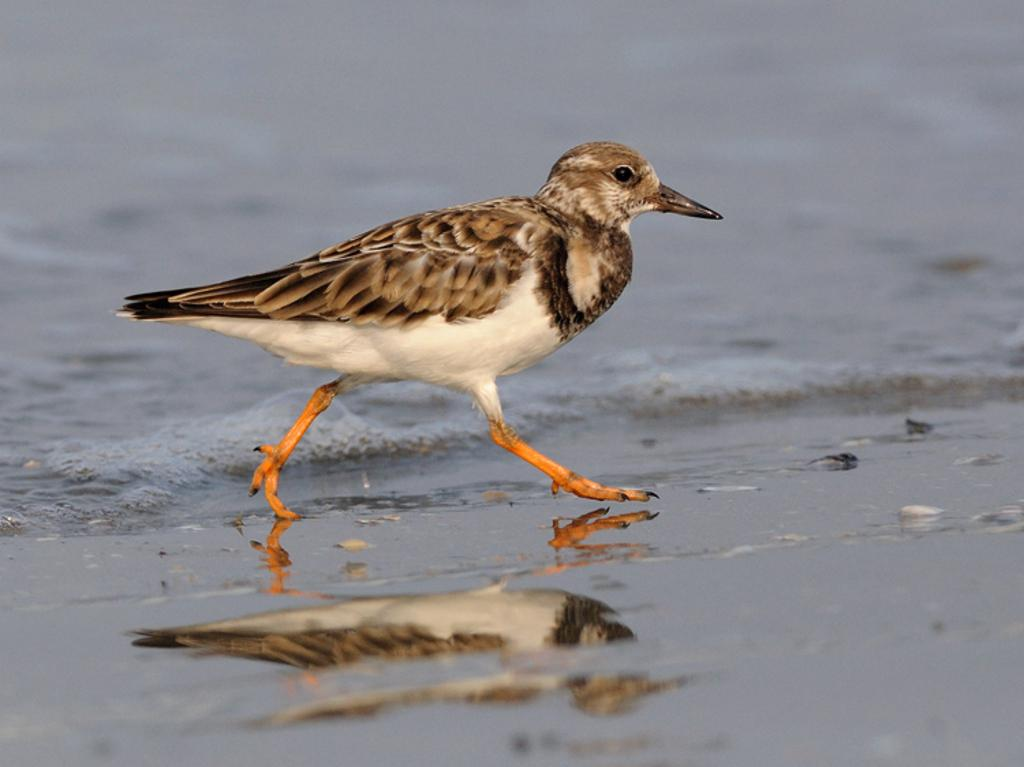What is the main subject in the center of the image? There is a bird in the center of the image. What type of environment can be seen in the background of the image? There is a beach in the background of the image. What type of terrain is present at the bottom of the image? Sand is present at the bottom of the image. What type of property does the bird own in the image? There is no indication of property ownership in the image, as it features a bird and a beach. 